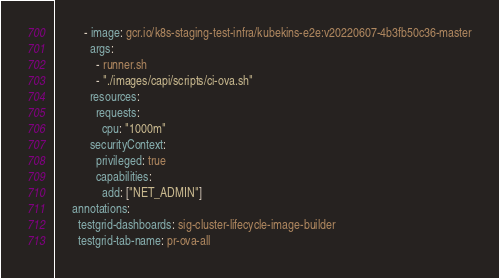Convert code to text. <code><loc_0><loc_0><loc_500><loc_500><_YAML_>          - image: gcr.io/k8s-staging-test-infra/kubekins-e2e:v20220607-4b3fb50c36-master
            args:
              - runner.sh
              - "./images/capi/scripts/ci-ova.sh"
            resources:
              requests:
                cpu: "1000m"
            securityContext:
              privileged: true
              capabilities:
                add: ["NET_ADMIN"]
      annotations:
        testgrid-dashboards: sig-cluster-lifecycle-image-builder
        testgrid-tab-name: pr-ova-all
</code> 